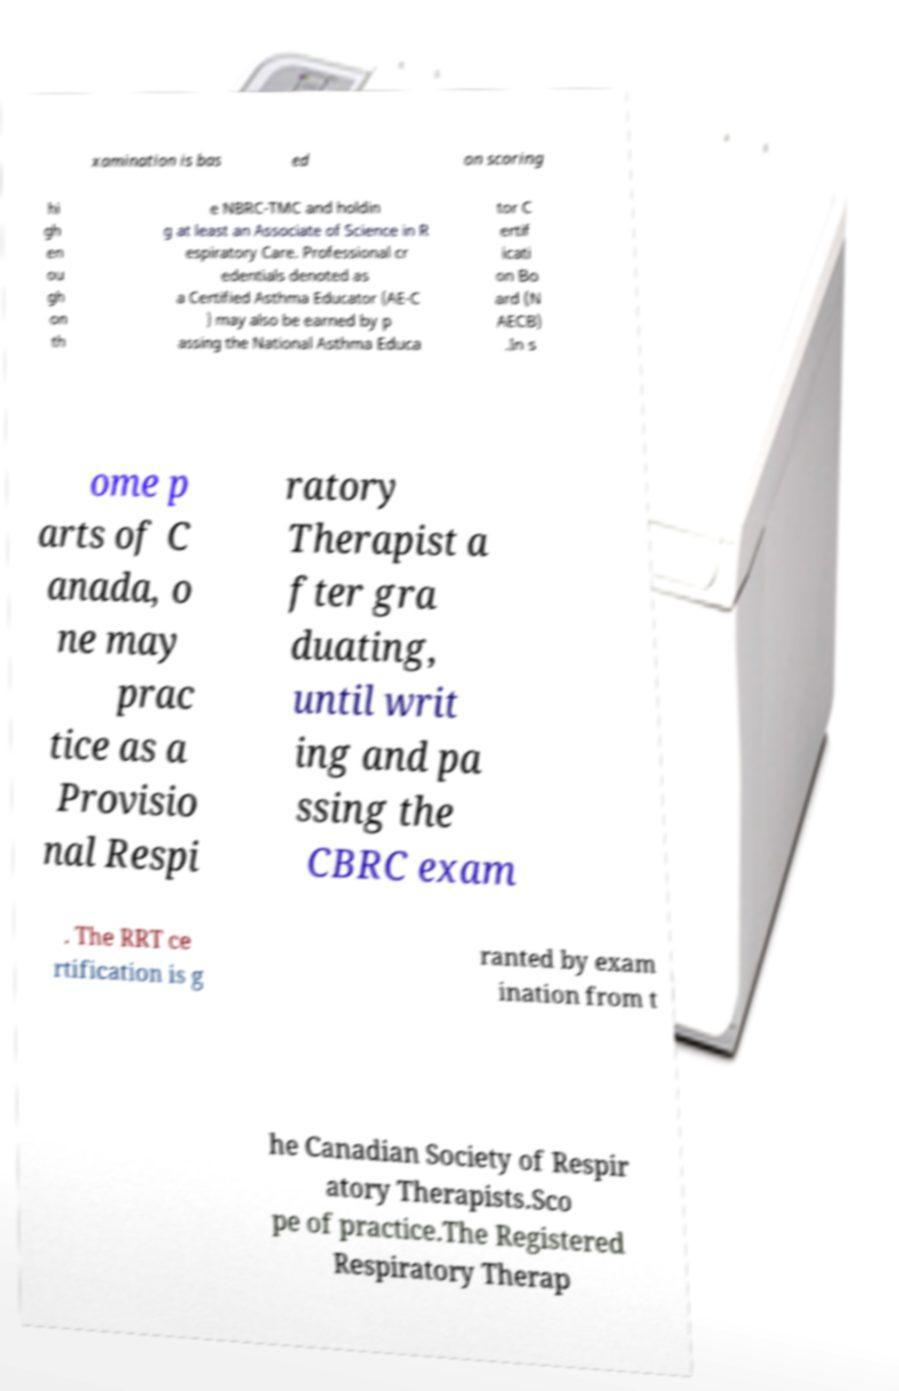I need the written content from this picture converted into text. Can you do that? xamination is bas ed on scoring hi gh en ou gh on th e NBRC-TMC and holdin g at least an Associate of Science in R espiratory Care. Professional cr edentials denoted as a Certified Asthma Educator (AE-C ) may also be earned by p assing the National Asthma Educa tor C ertif icati on Bo ard (N AECB) .In s ome p arts of C anada, o ne may prac tice as a Provisio nal Respi ratory Therapist a fter gra duating, until writ ing and pa ssing the CBRC exam . The RRT ce rtification is g ranted by exam ination from t he Canadian Society of Respir atory Therapists.Sco pe of practice.The Registered Respiratory Therap 